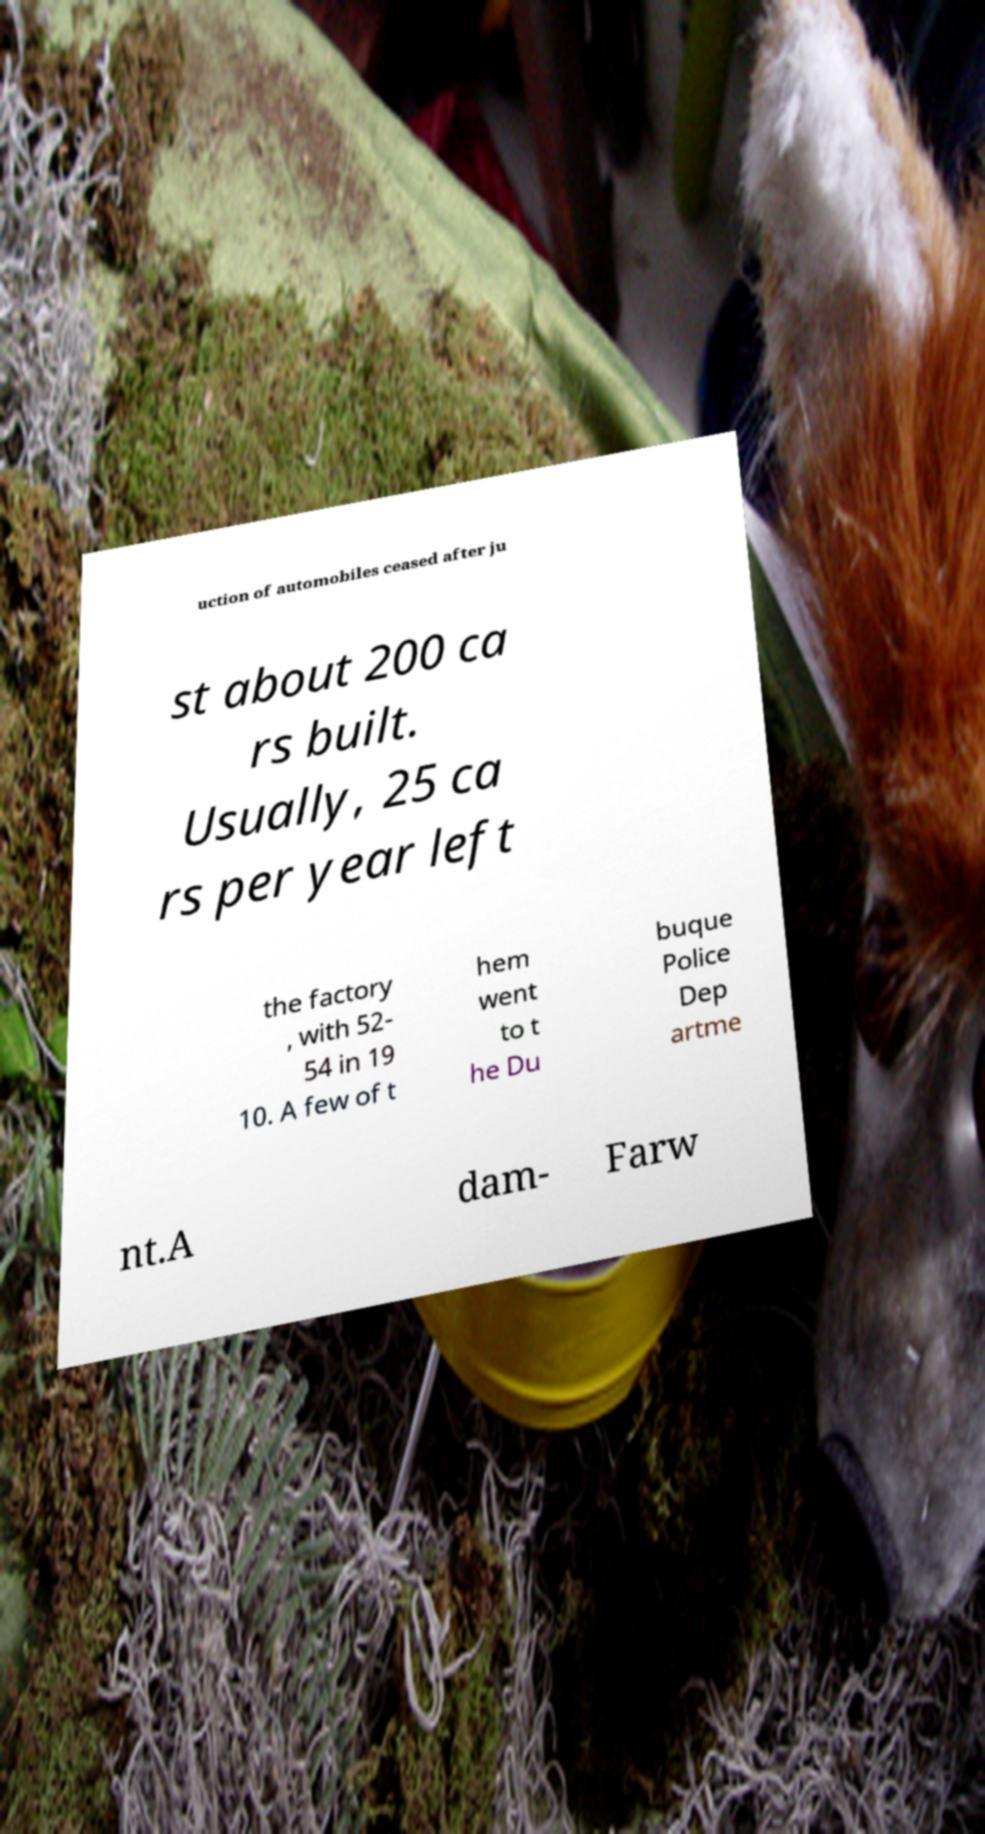Can you read and provide the text displayed in the image?This photo seems to have some interesting text. Can you extract and type it out for me? uction of automobiles ceased after ju st about 200 ca rs built. Usually, 25 ca rs per year left the factory , with 52- 54 in 19 10. A few of t hem went to t he Du buque Police Dep artme nt.A dam- Farw 